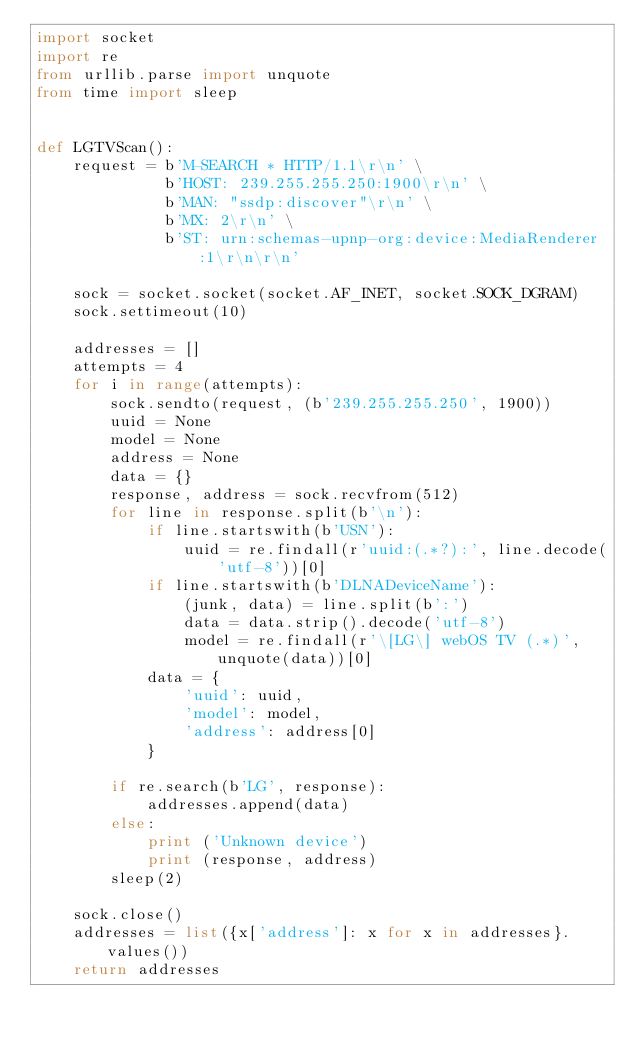<code> <loc_0><loc_0><loc_500><loc_500><_Python_>import socket
import re
from urllib.parse import unquote
from time import sleep


def LGTVScan():
    request = b'M-SEARCH * HTTP/1.1\r\n' \
              b'HOST: 239.255.255.250:1900\r\n' \
              b'MAN: "ssdp:discover"\r\n' \
              b'MX: 2\r\n' \
              b'ST: urn:schemas-upnp-org:device:MediaRenderer:1\r\n\r\n'

    sock = socket.socket(socket.AF_INET, socket.SOCK_DGRAM)
    sock.settimeout(10)

    addresses = []
    attempts = 4
    for i in range(attempts):
        sock.sendto(request, (b'239.255.255.250', 1900))
        uuid = None
        model = None
        address = None
        data = {}
        response, address = sock.recvfrom(512)
        for line in response.split(b'\n'):
            if line.startswith(b'USN'):
                uuid = re.findall(r'uuid:(.*?):', line.decode('utf-8'))[0]
            if line.startswith(b'DLNADeviceName'):
                (junk, data) = line.split(b':')
                data = data.strip().decode('utf-8')
                model = re.findall(r'\[LG\] webOS TV (.*)', unquote(data))[0]
            data = {
                'uuid': uuid,
                'model': model,
                'address': address[0]
            }

        if re.search(b'LG', response):
            addresses.append(data)
        else:
            print ('Unknown device')
            print (response, address)
        sleep(2)

    sock.close()
    addresses = list({x['address']: x for x in addresses}.values())
    return addresses
</code> 